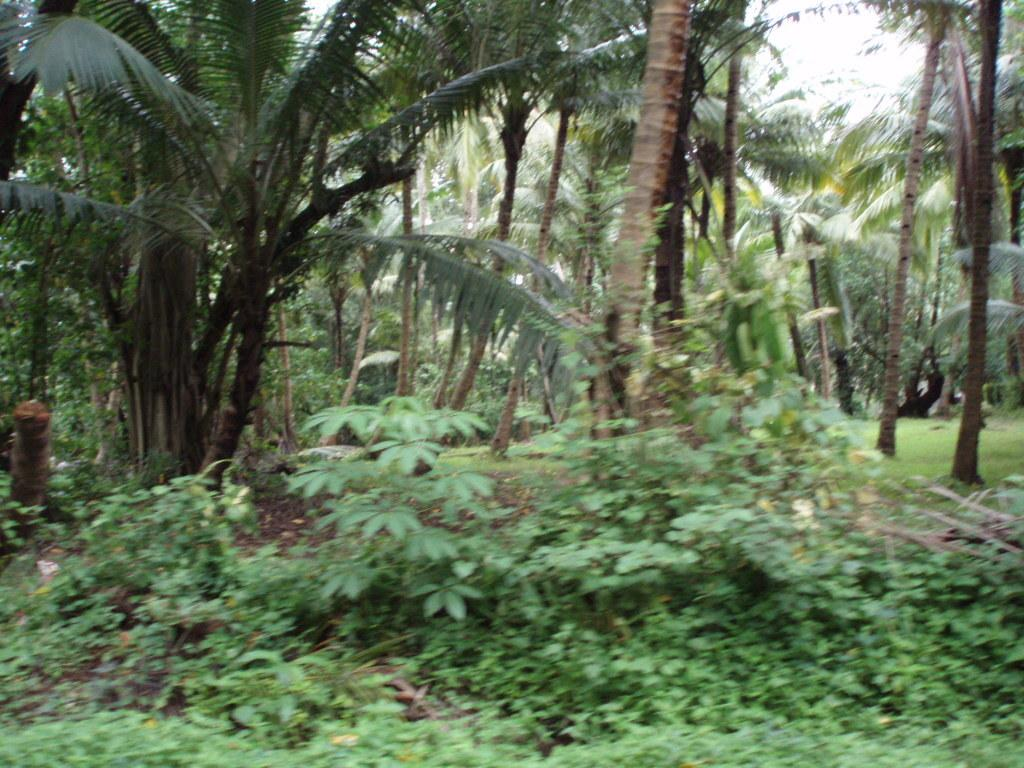What types of vegetation are present at the bottom of the picture? There are plants and shrubs at the bottom of the picture. What can be seen in the background of the image? There are trees in the background of the image. What type of location might the picture be taken in? The picture is likely taken in a garden or a coconut field. How many brothers are playing with the ball in the image? There are no brothers or balls present in the image; it features plants, shrubs, and trees. Can you tell me the color of the cow in the image? There is no cow present in the image. 